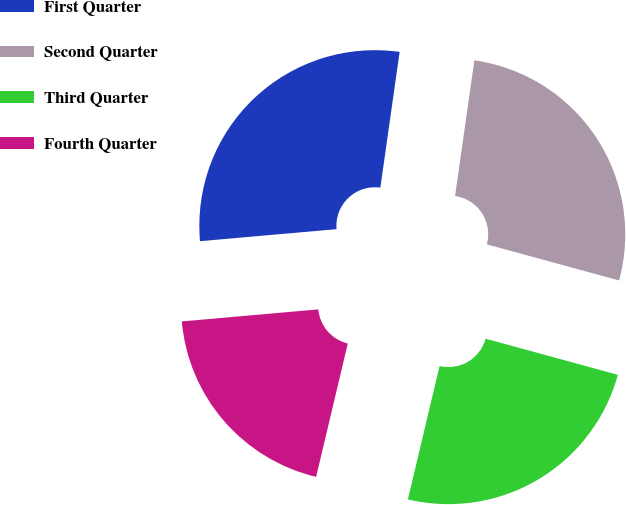Convert chart. <chart><loc_0><loc_0><loc_500><loc_500><pie_chart><fcel>First Quarter<fcel>Second Quarter<fcel>Third Quarter<fcel>Fourth Quarter<nl><fcel>28.65%<fcel>27.0%<fcel>24.47%<fcel>19.89%<nl></chart> 